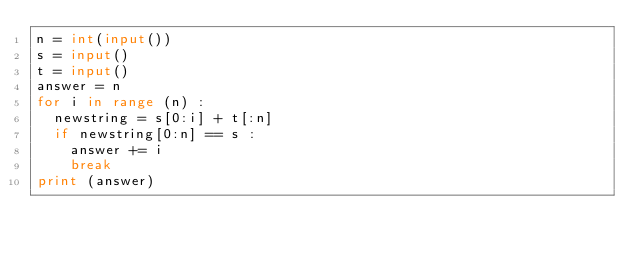<code> <loc_0><loc_0><loc_500><loc_500><_Python_>n = int(input())
s = input()
t = input()
answer = n
for i in range (n) :
  newstring = s[0:i] + t[:n]
  if newstring[0:n] == s :
    answer += i
    break
print (answer)</code> 